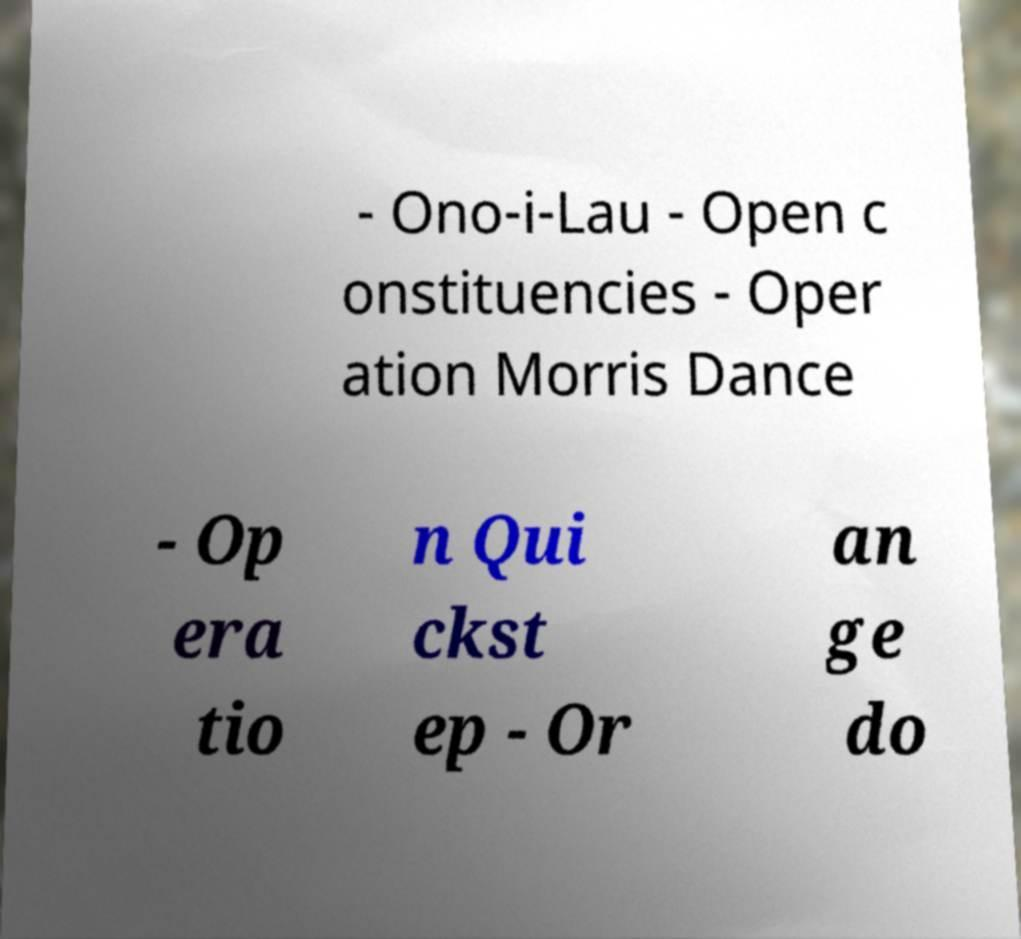Can you accurately transcribe the text from the provided image for me? - Ono-i-Lau - Open c onstituencies - Oper ation Morris Dance - Op era tio n Qui ckst ep - Or an ge do 